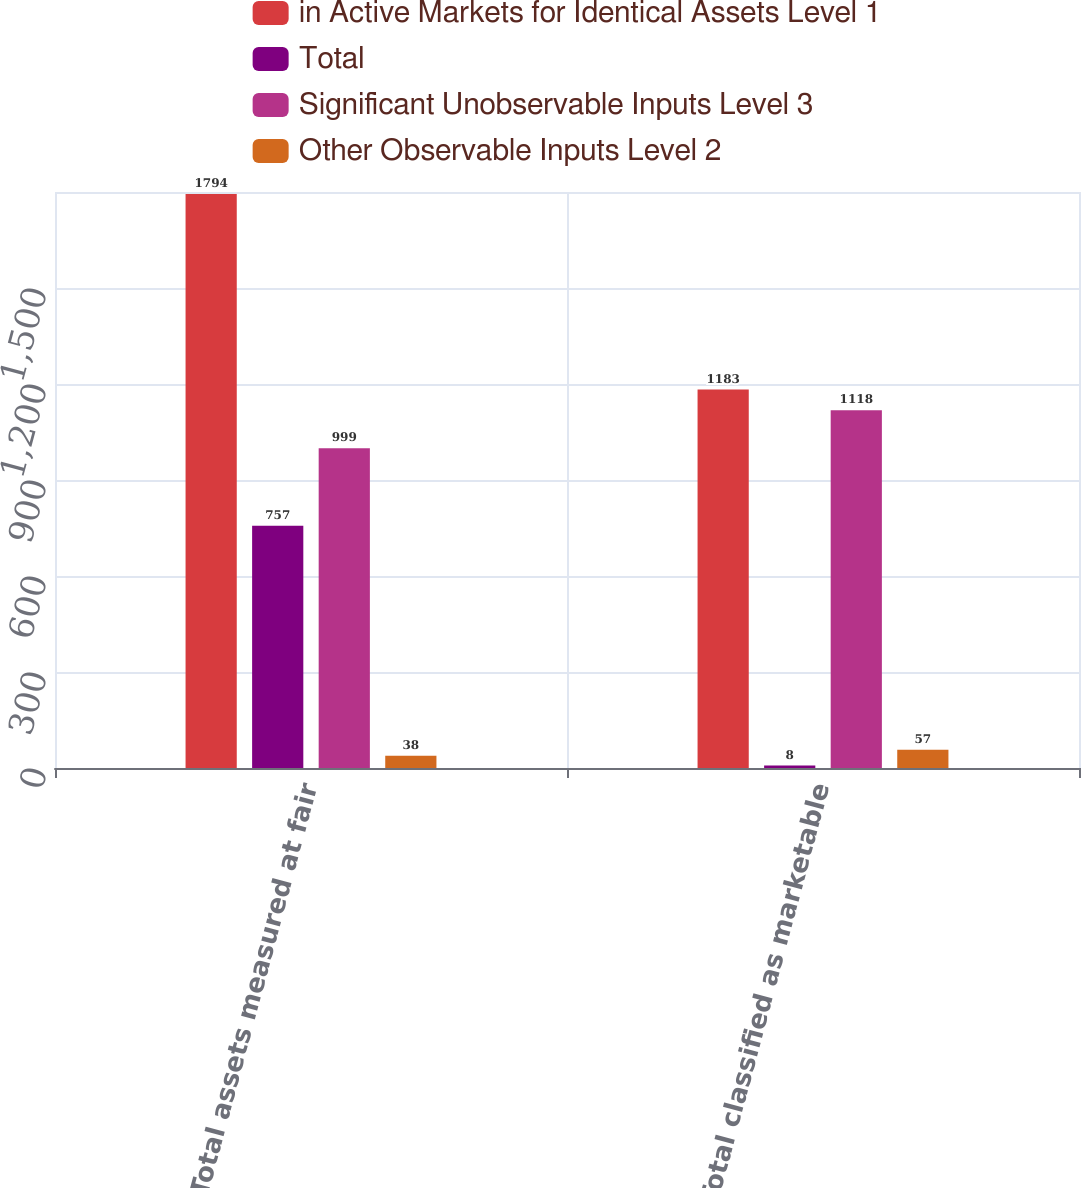<chart> <loc_0><loc_0><loc_500><loc_500><stacked_bar_chart><ecel><fcel>Total assets measured at fair<fcel>Total classified as marketable<nl><fcel>in Active Markets for Identical Assets Level 1<fcel>1794<fcel>1183<nl><fcel>Total<fcel>757<fcel>8<nl><fcel>Significant Unobservable Inputs Level 3<fcel>999<fcel>1118<nl><fcel>Other Observable Inputs Level 2<fcel>38<fcel>57<nl></chart> 